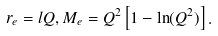Convert formula to latex. <formula><loc_0><loc_0><loc_500><loc_500>r _ { e } = l Q , M _ { e } = Q ^ { 2 } \left [ 1 - \ln ( Q ^ { 2 } ) \right ] .</formula> 